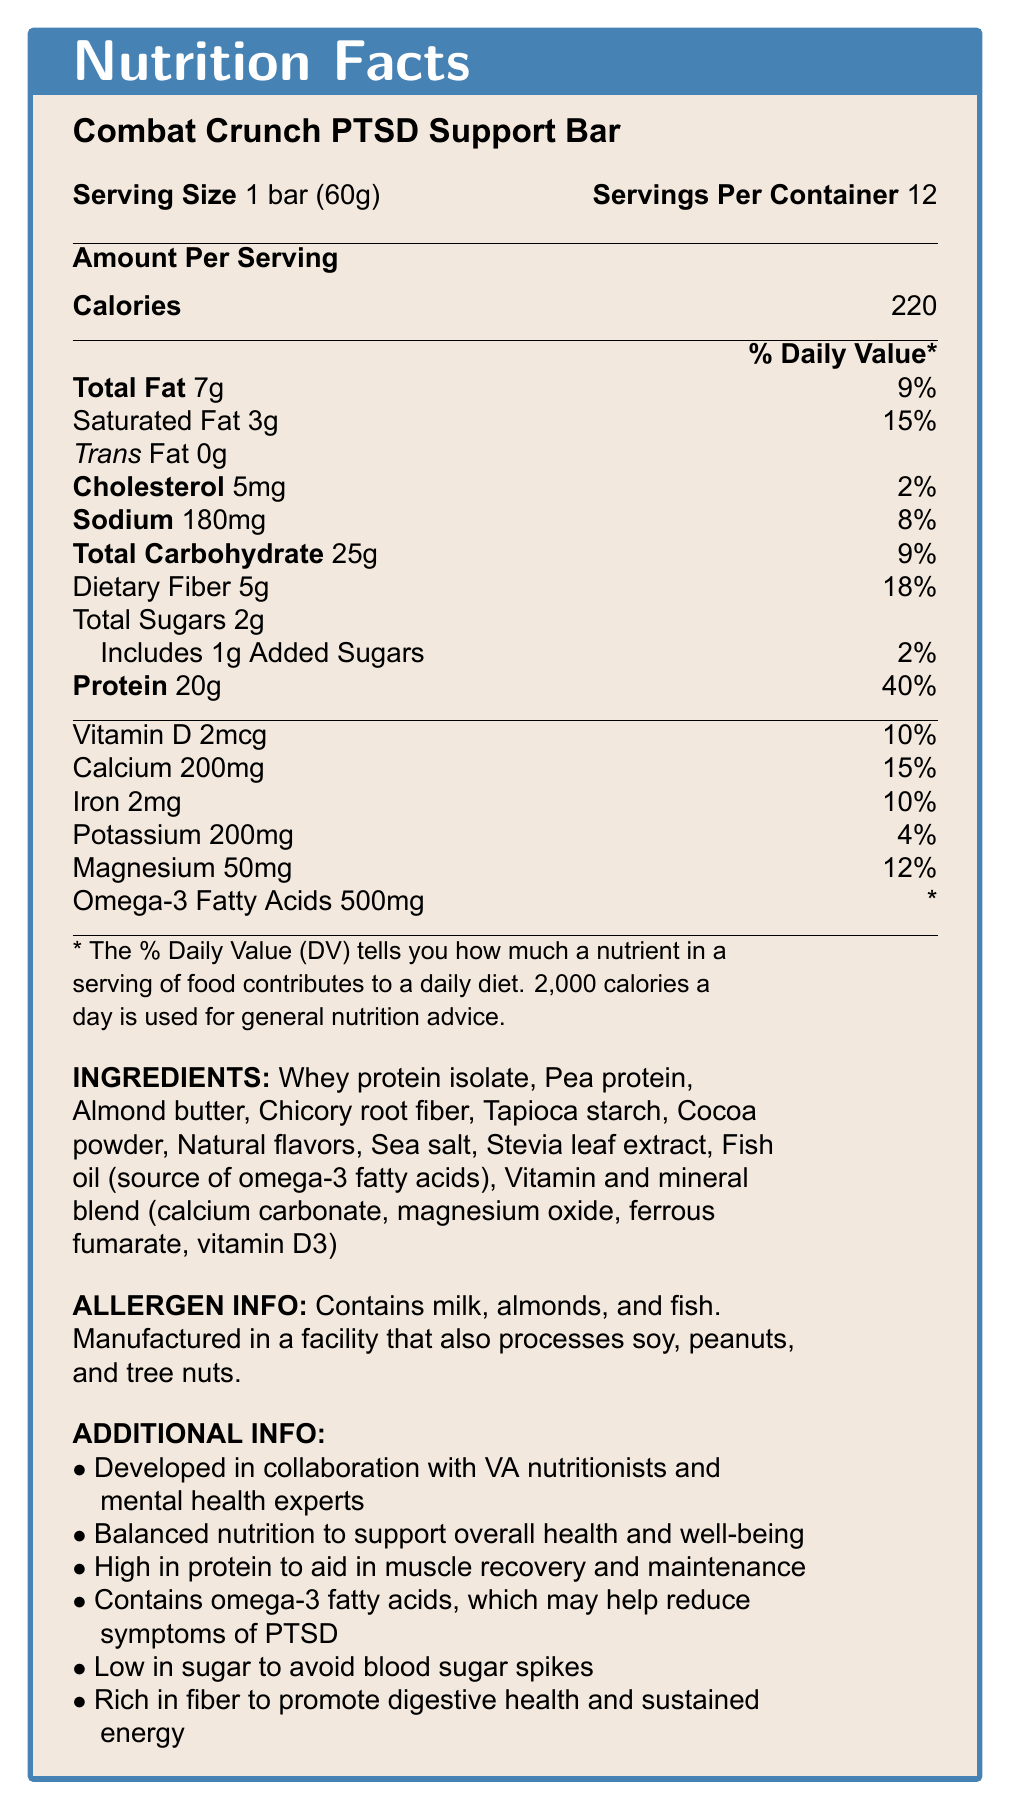what is the serving size for the Combat Crunch PTSD Support Bar? The serving size is clearly indicated as "1 bar (60g)" in the document.
Answer: 1 bar (60g) how much protein does one serving provide? The document specifies that one serving contains 20g of protein.
Answer: 20g how many grams of dietary fiber are in one serving? 5g of dietary fiber is listed under the Total Carbohydrate section.
Answer: 5g how many calories are in one bar? The amount of calories per serving is listed as 220.
Answer: 220 what are the main ingredients in the Combat Crunch PTSD Support Bar? The main ingredients are listed under the INGREDIENTS section.
Answer: Whey protein isolate, Pea protein, Almond butter, Chicory root fiber, Tapioca starch, Cocoa powder, Natural flavors, Sea salt, Stevia leaf extract, Fish oil, Vitamin and mineral blend what percentage of Daily Value is the saturated fat content? A. 9% B. 15% C. 2% D. 40% The document states that the saturated fat content is 3g, which is 15% of the daily value.
Answer: B. 15% what nutrient in the Combat Crunch PTSD Support Bar has the highest percentage of Daily Value? A. Calcium B. Protein C. Magnesium D. Dietary Fiber Protein has a Daily Value percentage of 40%, which is the highest among all listed nutrients.
Answer: B. Protein does this product contain any allergens? The allergen information section states that the product contains milk, almonds, and fish.
Answer: Yes was the Combat Crunch PTSD Support Bar developed independently? The document mentions that the product was developed in collaboration with VA nutritionists and mental health experts.
Answer: No summarize the main features of the Combat Crunch PTSD Support Bar. The bar offers balanced nutrition to aid muscle recovery, digestive health, and symptom management for PTSD, created with expert insight for veterans' specific needs.
Answer: The Combat Crunch PTSD Support Bar is a protein-rich snack designed for veterans with PTSD. It contains 20 grams of protein per bar, along with significant amounts of dietary fiber and omega-3 fatty acids. The product is low in sugar and includes beneficial nutrients such as calcium, iron, and magnesium. It is developed in collaboration with VA nutritionists and mental health experts to support overall health and well-being. Additionally, it contains allergens such as milk, almonds, and fish. how much omega-3 fatty acids does one bar contain? The amount of omega-3 fatty acids per serving is specified as 500mg.
Answer: 500mg what is the total amount of sugar (including added sugars) in one serving? The document lists total sugars as 2g and added sugars as 1g, but the total sugars, including added sugars, is still mentioned as 2g.
Answer: 2g how many servings are there per container? The number of servings per container is given as 12.
Answer: 12 can the precise amount of DHA or EPA in the omega-3 fatty acids be determined from the document? The document only states the total amount of omega-3 fatty acids without specifying the DHA or EPA content.
Answer: Not enough information does the product support muscle recovery and maintenance? One of the additional info points is that the product is high in protein to aid muscle recovery and maintenance.
Answer: Yes is the saturated fat content in one bar higher or lower than the recommended daily value percentage for this nutrient? The document shows the saturated fat content is 15% of the daily value, meaning it contributes to but does not exceed the recommended amount in one serving.
Answer: Lower 